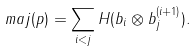<formula> <loc_0><loc_0><loc_500><loc_500>m a j ( p ) = \sum _ { i < j } H ( b _ { i } \otimes b _ { j } ^ { ( i + 1 ) } ) .</formula> 